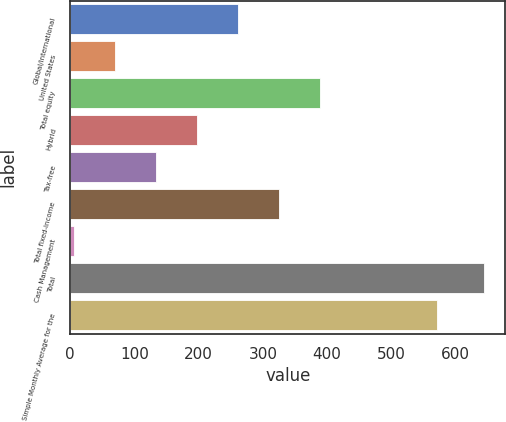<chart> <loc_0><loc_0><loc_500><loc_500><bar_chart><fcel>Global/international<fcel>United States<fcel>Total equity<fcel>Hybrid<fcel>Tax-free<fcel>Total fixed-income<fcel>Cash Management<fcel>Total<fcel>Simple Monthly Average for the<nl><fcel>261.92<fcel>70.43<fcel>389.58<fcel>198.09<fcel>134.26<fcel>325.75<fcel>6.6<fcel>644.9<fcel>571.1<nl></chart> 